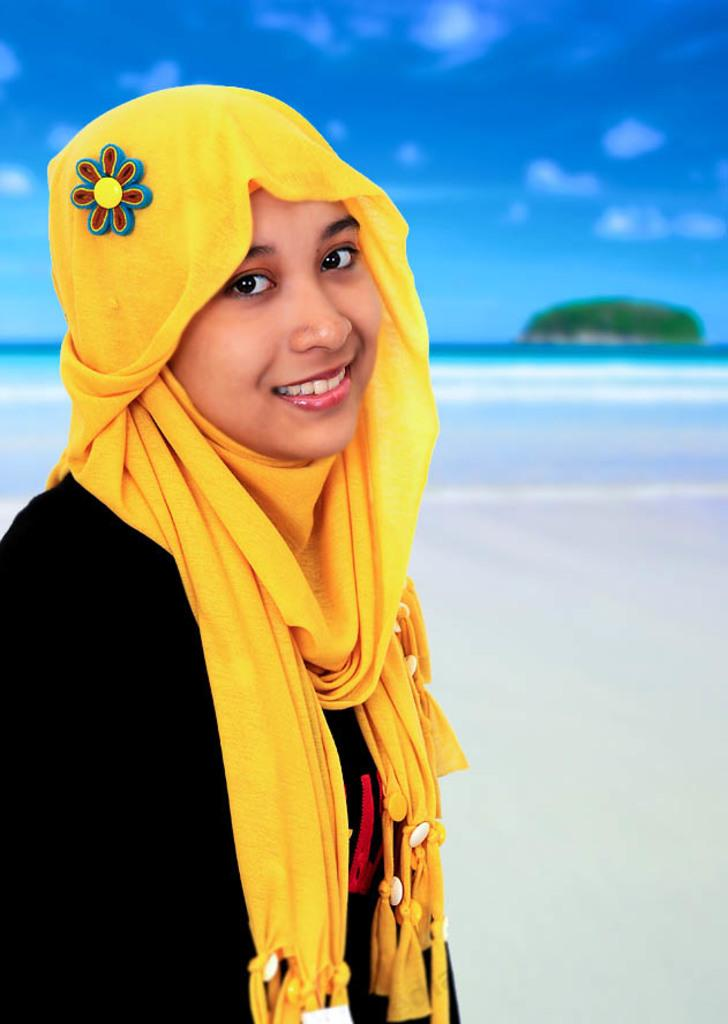Who is the main subject in the image? There is a lady in the image. What is the lady wearing? The lady is wearing a black dress. What can be seen in the left corner of the image? There is a yellow color cloth in the left corner of the image. What is visible in the background of the image? There is water visible in the background of the image. What is the color of the sky in the image? The sky is blue in color. What type of border is present around the lady in the image? There is no border present around the lady in the image. How is the tax calculated for the yellow cloth in the image? There is no tax calculation involved in the image, as it is not a commercial scene. 